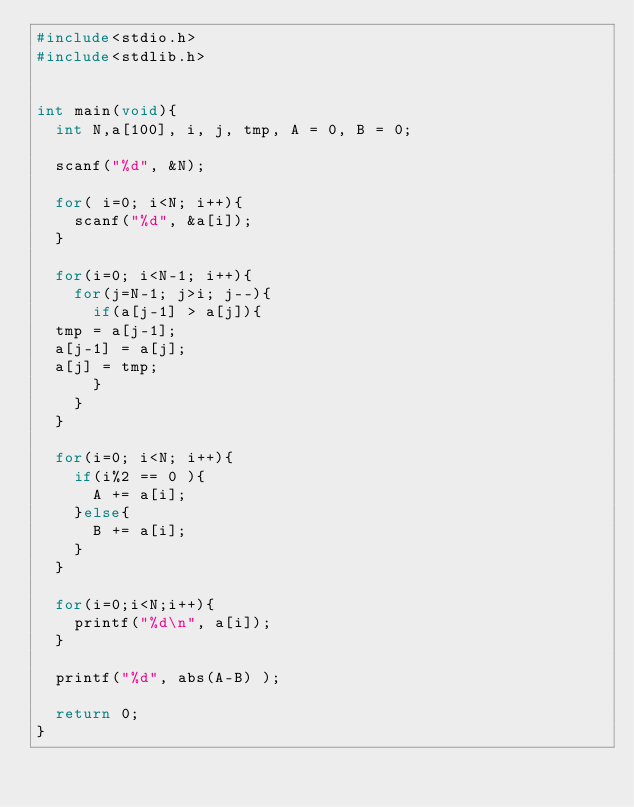<code> <loc_0><loc_0><loc_500><loc_500><_C_>#include<stdio.h>
#include<stdlib.h>


int main(void){
  int N,a[100], i, j, tmp, A = 0, B = 0;

  scanf("%d", &N);
  
  for( i=0; i<N; i++){
    scanf("%d", &a[i]);
  }

  for(i=0; i<N-1; i++){
    for(j=N-1; j>i; j--){
      if(a[j-1] > a[j]){
	tmp = a[j-1];
	a[j-1] = a[j];
	a[j] = tmp;
      }
    }
  }

  for(i=0; i<N; i++){
    if(i%2 == 0 ){
      A += a[i];
    }else{
      B += a[i];
    }
  }

  for(i=0;i<N;i++){
    printf("%d\n", a[i]);
  }

  printf("%d", abs(A-B) );
  
  return 0;
}
</code> 